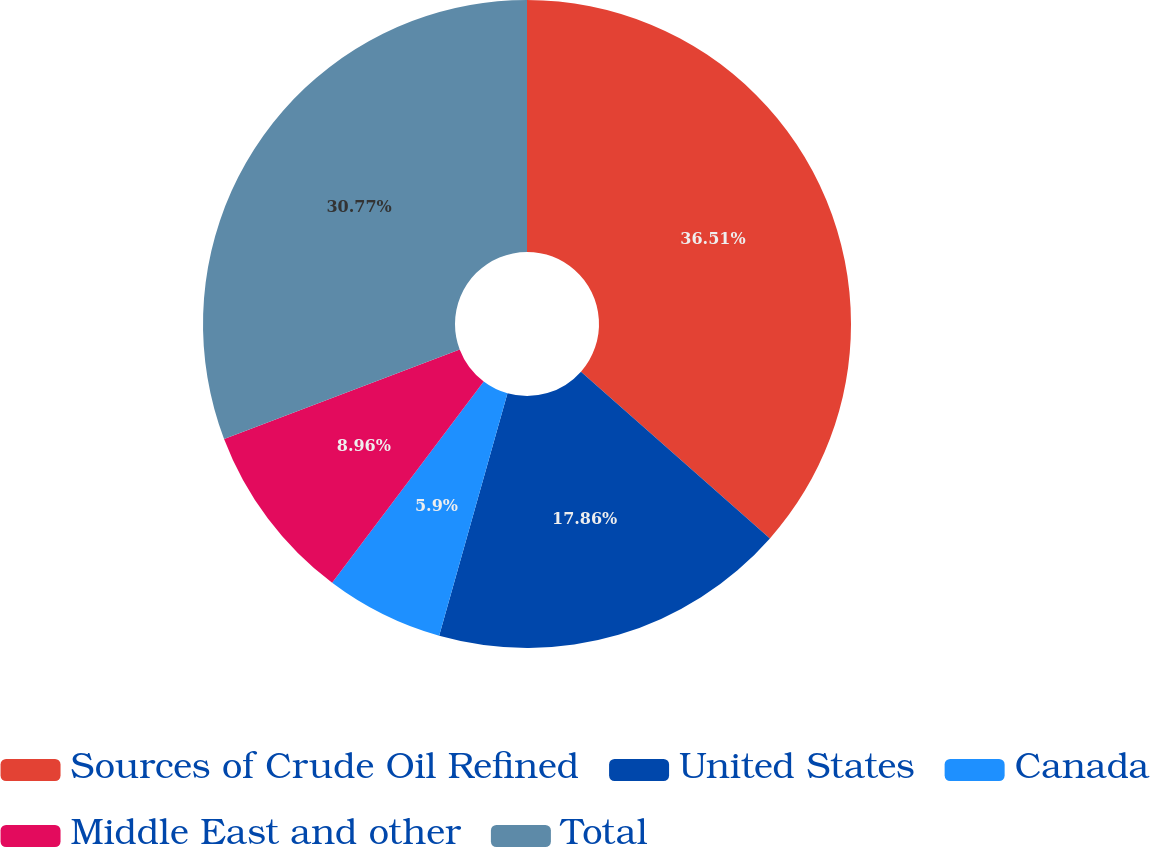Convert chart. <chart><loc_0><loc_0><loc_500><loc_500><pie_chart><fcel>Sources of Crude Oil Refined<fcel>United States<fcel>Canada<fcel>Middle East and other<fcel>Total<nl><fcel>36.51%<fcel>17.86%<fcel>5.9%<fcel>8.96%<fcel>30.77%<nl></chart> 